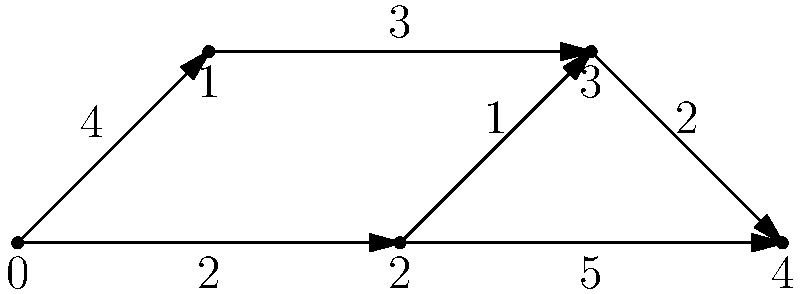In the weighted directed graph shown above, what is the shortest path from node 0 to node 4, and what is its total weight? Assume that the weight of each edge represents the cost of traversing that edge. To find the shortest path, we'll use Dijkstra's algorithm:

1. Initialize distances: d[0]=0, d[1]=∞, d[2]=∞, d[3]=∞, d[4]=∞
2. Start from node 0:
   - Update d[1] = min(∞, 0+4) = 4
   - Update d[2] = min(∞, 0+2) = 2
3. Select node 2 (smallest unvisited):
   - Update d[3] = min(∞, 2+1) = 3
   - Update d[4] = min(∞, 2+5) = 7
4. Select node 3 (smallest unvisited):
   - Update d[4] = min(7, 3+2) = 5
5. Select node 1 (smallest unvisited):
   - No updates needed
6. Select node 4 (last unvisited):
   - Algorithm complete

The shortest path is 0 → 2 → 3 → 4, with a total weight of 5.
Answer: Path: 0 → 2 → 3 → 4, Weight: 5 